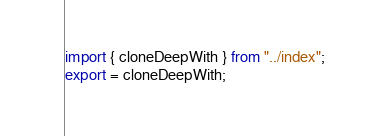Convert code to text. <code><loc_0><loc_0><loc_500><loc_500><_TypeScript_>import { cloneDeepWith } from "../index";
export = cloneDeepWith;</code> 